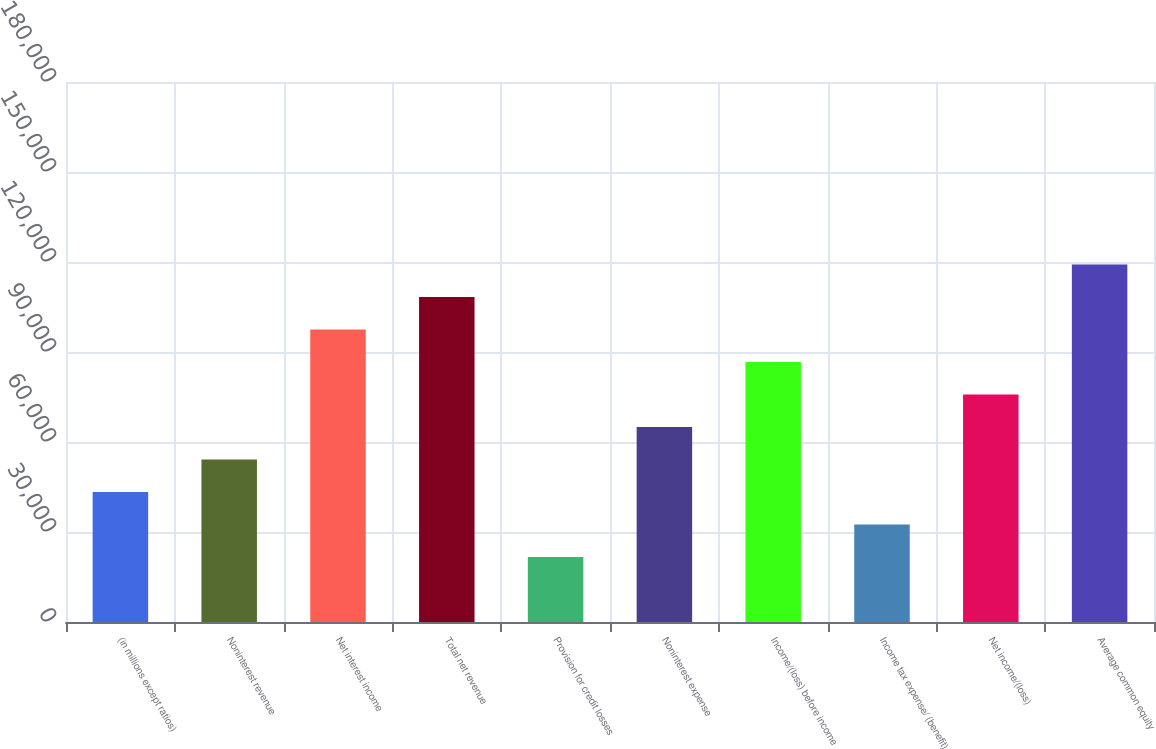<chart> <loc_0><loc_0><loc_500><loc_500><bar_chart><fcel>(in millions except ratios)<fcel>Noninterest revenue<fcel>Net interest income<fcel>Total net revenue<fcel>Provision for credit losses<fcel>Noninterest expense<fcel>Income/(loss) before income<fcel>Income tax expense/ (benefit)<fcel>Net income/(loss)<fcel>Average common equity<nl><fcel>63234<fcel>79035<fcel>142239<fcel>158040<fcel>31632<fcel>94836<fcel>126438<fcel>47433<fcel>110637<fcel>173841<nl></chart> 